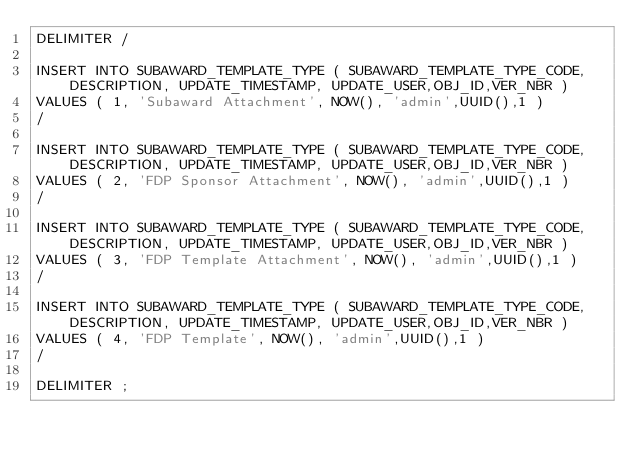Convert code to text. <code><loc_0><loc_0><loc_500><loc_500><_SQL_>DELIMITER /

INSERT INTO SUBAWARD_TEMPLATE_TYPE ( SUBAWARD_TEMPLATE_TYPE_CODE, DESCRIPTION, UPDATE_TIMESTAMP, UPDATE_USER,OBJ_ID,VER_NBR ) 
VALUES ( 1, 'Subaward Attachment', NOW(), 'admin',UUID(),1 )
/

INSERT INTO SUBAWARD_TEMPLATE_TYPE ( SUBAWARD_TEMPLATE_TYPE_CODE, DESCRIPTION, UPDATE_TIMESTAMP, UPDATE_USER,OBJ_ID,VER_NBR ) 
VALUES ( 2, 'FDP Sponsor Attachment', NOW(), 'admin',UUID(),1 )
/

INSERT INTO SUBAWARD_TEMPLATE_TYPE ( SUBAWARD_TEMPLATE_TYPE_CODE, DESCRIPTION, UPDATE_TIMESTAMP, UPDATE_USER,OBJ_ID,VER_NBR ) 
VALUES ( 3, 'FDP Template Attachment', NOW(), 'admin',UUID(),1 )
/

INSERT INTO SUBAWARD_TEMPLATE_TYPE ( SUBAWARD_TEMPLATE_TYPE_CODE, DESCRIPTION, UPDATE_TIMESTAMP, UPDATE_USER,OBJ_ID,VER_NBR ) 
VALUES ( 4, 'FDP Template', NOW(), 'admin',UUID(),1 )
/

DELIMITER ;
</code> 